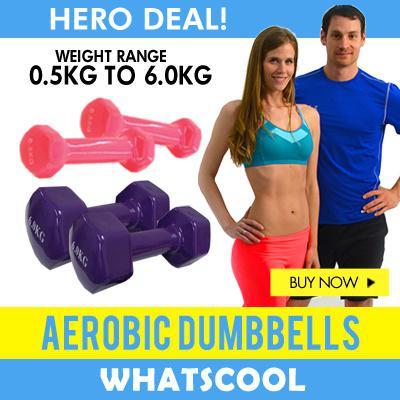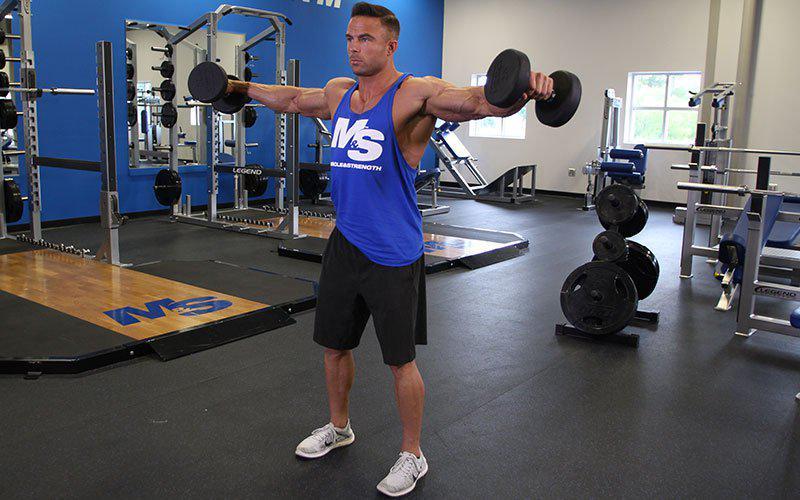The first image is the image on the left, the second image is the image on the right. Assess this claim about the two images: "In one of the images, someone is exercising, and in the other image, people are posing.". Correct or not? Answer yes or no. Yes. 